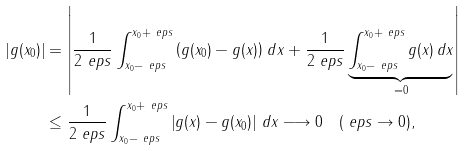<formula> <loc_0><loc_0><loc_500><loc_500>| g ( x _ { 0 } ) | & = \left | \frac { 1 } { 2 \ e p s } \int _ { x _ { 0 } - \ e p s } ^ { x _ { 0 } + \ e p s } \left ( g ( x _ { 0 } ) - g ( x ) \right ) \, d x + \frac { 1 } { 2 \ e p s } \underbrace { \int _ { x _ { 0 } - \ e p s } ^ { x _ { 0 } + \ e p s } g ( x ) \, d x } _ { = 0 } \right | \\ & \leq \frac { 1 } { 2 \ e p s } \int _ { x _ { 0 } - \ e p s } ^ { x _ { 0 } + \ e p s } \left | g ( x ) - g ( x _ { 0 } ) \right | \, d x \longrightarrow 0 \quad ( \ e p s \to 0 ) ,</formula> 